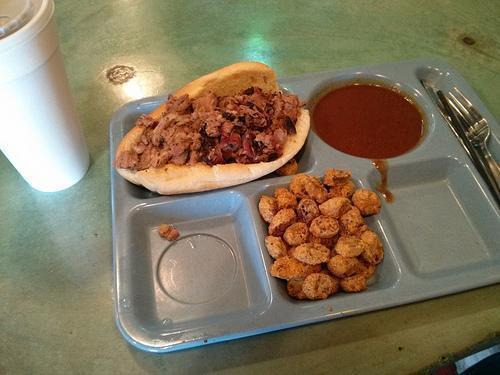How many compartments are in the tray?
Give a very brief answer. 5. 